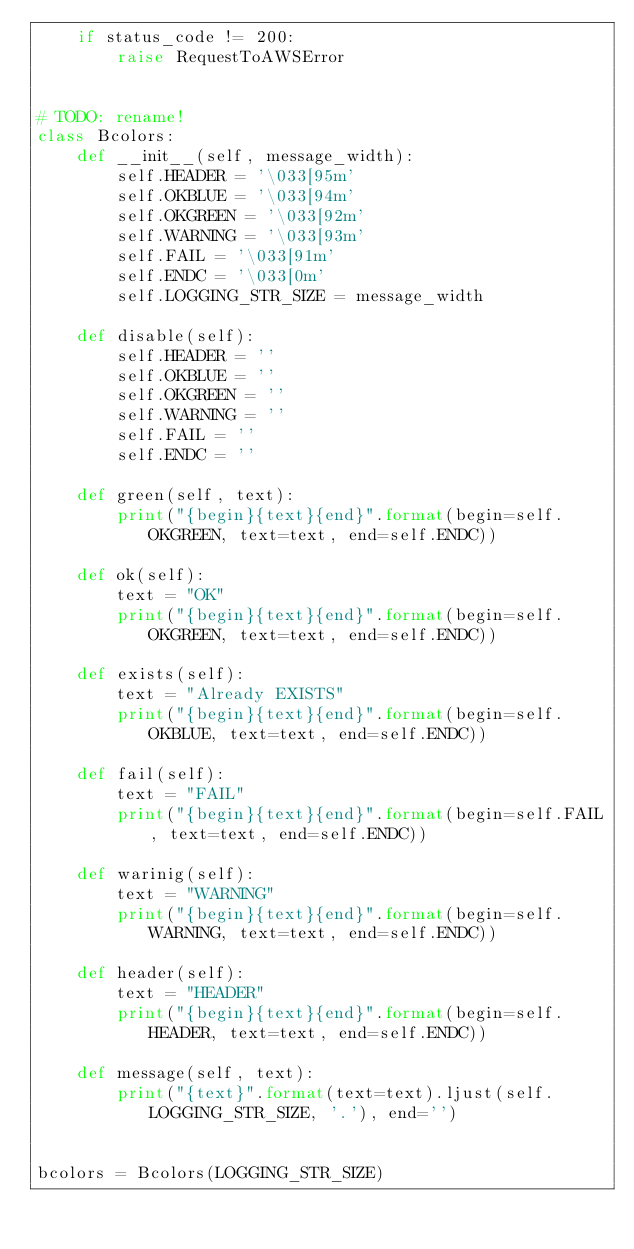Convert code to text. <code><loc_0><loc_0><loc_500><loc_500><_Python_>    if status_code != 200:
        raise RequestToAWSError


# TODO: rename!
class Bcolors:
    def __init__(self, message_width):
        self.HEADER = '\033[95m'
        self.OKBLUE = '\033[94m'
        self.OKGREEN = '\033[92m'
        self.WARNING = '\033[93m'
        self.FAIL = '\033[91m'
        self.ENDC = '\033[0m'
        self.LOGGING_STR_SIZE = message_width

    def disable(self):
        self.HEADER = ''
        self.OKBLUE = ''
        self.OKGREEN = ''
        self.WARNING = ''
        self.FAIL = ''
        self.ENDC = ''

    def green(self, text):
        print("{begin}{text}{end}".format(begin=self.OKGREEN, text=text, end=self.ENDC))

    def ok(self):
        text = "OK"
        print("{begin}{text}{end}".format(begin=self.OKGREEN, text=text, end=self.ENDC))

    def exists(self):
        text = "Already EXISTS"
        print("{begin}{text}{end}".format(begin=self.OKBLUE, text=text, end=self.ENDC))

    def fail(self):
        text = "FAIL"
        print("{begin}{text}{end}".format(begin=self.FAIL, text=text, end=self.ENDC))

    def warinig(self):
        text = "WARNING"
        print("{begin}{text}{end}".format(begin=self.WARNING, text=text, end=self.ENDC))

    def header(self):
        text = "HEADER"
        print("{begin}{text}{end}".format(begin=self.HEADER, text=text, end=self.ENDC))

    def message(self, text):
        print("{text}".format(text=text).ljust(self.LOGGING_STR_SIZE, '.'), end='')


bcolors = Bcolors(LOGGING_STR_SIZE)
</code> 